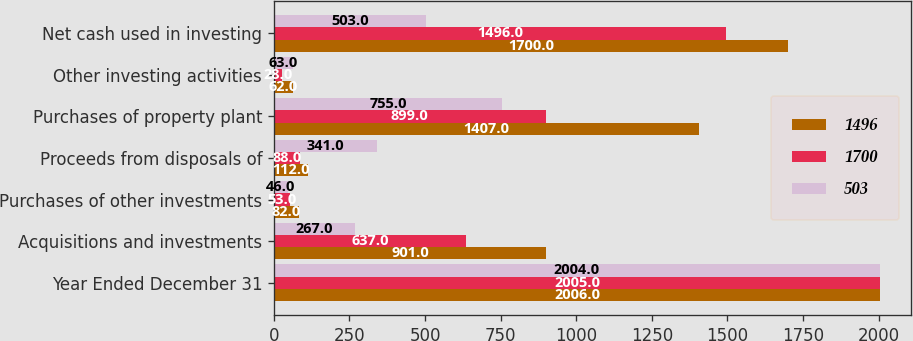Convert chart to OTSL. <chart><loc_0><loc_0><loc_500><loc_500><stacked_bar_chart><ecel><fcel>Year Ended December 31<fcel>Acquisitions and investments<fcel>Purchases of other investments<fcel>Proceeds from disposals of<fcel>Purchases of property plant<fcel>Other investing activities<fcel>Net cash used in investing<nl><fcel>1496<fcel>2006<fcel>901<fcel>82<fcel>112<fcel>1407<fcel>62<fcel>1700<nl><fcel>1700<fcel>2005<fcel>637<fcel>53<fcel>88<fcel>899<fcel>28<fcel>1496<nl><fcel>503<fcel>2004<fcel>267<fcel>46<fcel>341<fcel>755<fcel>63<fcel>503<nl></chart> 